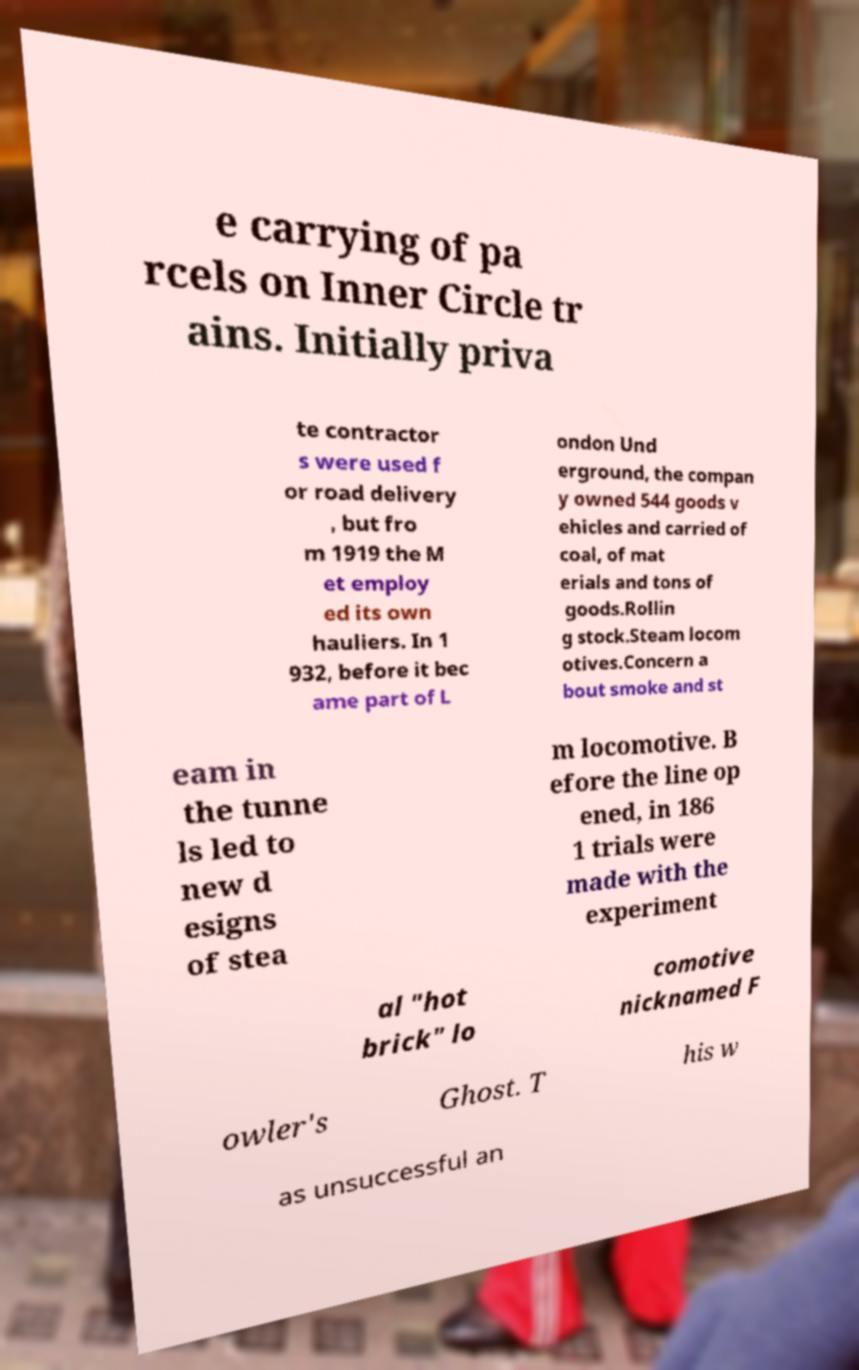Please identify and transcribe the text found in this image. e carrying of pa rcels on Inner Circle tr ains. Initially priva te contractor s were used f or road delivery , but fro m 1919 the M et employ ed its own hauliers. In 1 932, before it bec ame part of L ondon Und erground, the compan y owned 544 goods v ehicles and carried of coal, of mat erials and tons of goods.Rollin g stock.Steam locom otives.Concern a bout smoke and st eam in the tunne ls led to new d esigns of stea m locomotive. B efore the line op ened, in 186 1 trials were made with the experiment al "hot brick" lo comotive nicknamed F owler's Ghost. T his w as unsuccessful an 